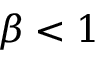Convert formula to latex. <formula><loc_0><loc_0><loc_500><loc_500>\beta < 1</formula> 